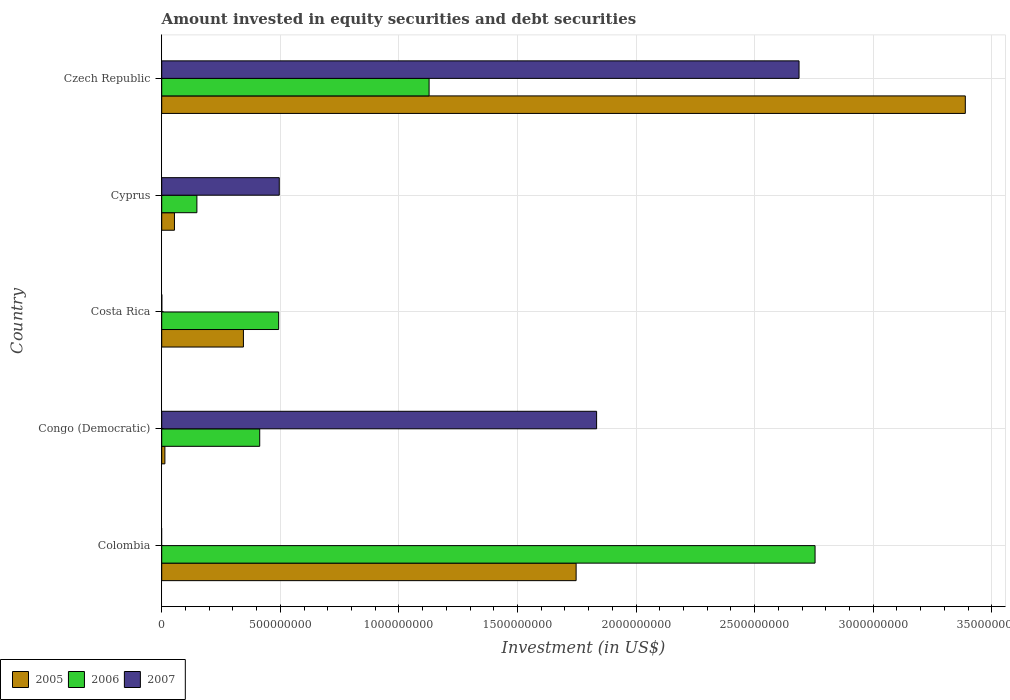Are the number of bars on each tick of the Y-axis equal?
Offer a very short reply. No. What is the label of the 5th group of bars from the top?
Make the answer very short. Colombia. What is the amount invested in equity securities and debt securities in 2006 in Czech Republic?
Offer a terse response. 1.13e+09. Across all countries, what is the maximum amount invested in equity securities and debt securities in 2005?
Your answer should be compact. 3.39e+09. Across all countries, what is the minimum amount invested in equity securities and debt securities in 2005?
Offer a very short reply. 1.34e+07. In which country was the amount invested in equity securities and debt securities in 2007 maximum?
Your response must be concise. Czech Republic. What is the total amount invested in equity securities and debt securities in 2007 in the graph?
Keep it short and to the point. 5.02e+09. What is the difference between the amount invested in equity securities and debt securities in 2007 in Costa Rica and that in Cyprus?
Your answer should be very brief. -4.95e+08. What is the difference between the amount invested in equity securities and debt securities in 2007 in Czech Republic and the amount invested in equity securities and debt securities in 2006 in Colombia?
Your answer should be compact. -6.75e+07. What is the average amount invested in equity securities and debt securities in 2006 per country?
Make the answer very short. 9.87e+08. What is the difference between the amount invested in equity securities and debt securities in 2007 and amount invested in equity securities and debt securities in 2005 in Costa Rica?
Offer a terse response. -3.44e+08. What is the ratio of the amount invested in equity securities and debt securities in 2005 in Colombia to that in Czech Republic?
Provide a short and direct response. 0.52. Is the amount invested in equity securities and debt securities in 2005 in Costa Rica less than that in Cyprus?
Your answer should be very brief. No. Is the difference between the amount invested in equity securities and debt securities in 2007 in Cyprus and Czech Republic greater than the difference between the amount invested in equity securities and debt securities in 2005 in Cyprus and Czech Republic?
Your answer should be compact. Yes. What is the difference between the highest and the second highest amount invested in equity securities and debt securities in 2005?
Offer a very short reply. 1.64e+09. What is the difference between the highest and the lowest amount invested in equity securities and debt securities in 2005?
Your answer should be compact. 3.37e+09. In how many countries, is the amount invested in equity securities and debt securities in 2005 greater than the average amount invested in equity securities and debt securities in 2005 taken over all countries?
Offer a very short reply. 2. Is the sum of the amount invested in equity securities and debt securities in 2007 in Cyprus and Czech Republic greater than the maximum amount invested in equity securities and debt securities in 2006 across all countries?
Provide a short and direct response. Yes. How many bars are there?
Your response must be concise. 14. Are all the bars in the graph horizontal?
Your answer should be compact. Yes. Does the graph contain grids?
Offer a very short reply. Yes. Where does the legend appear in the graph?
Your response must be concise. Bottom left. How many legend labels are there?
Your answer should be very brief. 3. What is the title of the graph?
Make the answer very short. Amount invested in equity securities and debt securities. Does "2014" appear as one of the legend labels in the graph?
Offer a very short reply. No. What is the label or title of the X-axis?
Your response must be concise. Investment (in US$). What is the label or title of the Y-axis?
Offer a very short reply. Country. What is the Investment (in US$) in 2005 in Colombia?
Offer a very short reply. 1.75e+09. What is the Investment (in US$) of 2006 in Colombia?
Ensure brevity in your answer.  2.75e+09. What is the Investment (in US$) in 2007 in Colombia?
Your response must be concise. 0. What is the Investment (in US$) in 2005 in Congo (Democratic)?
Your response must be concise. 1.34e+07. What is the Investment (in US$) of 2006 in Congo (Democratic)?
Make the answer very short. 4.13e+08. What is the Investment (in US$) of 2007 in Congo (Democratic)?
Offer a very short reply. 1.83e+09. What is the Investment (in US$) in 2005 in Costa Rica?
Provide a succinct answer. 3.45e+08. What is the Investment (in US$) in 2006 in Costa Rica?
Your answer should be very brief. 4.93e+08. What is the Investment (in US$) of 2007 in Costa Rica?
Offer a very short reply. 3.93e+05. What is the Investment (in US$) of 2005 in Cyprus?
Offer a terse response. 5.37e+07. What is the Investment (in US$) in 2006 in Cyprus?
Your response must be concise. 1.48e+08. What is the Investment (in US$) in 2007 in Cyprus?
Keep it short and to the point. 4.96e+08. What is the Investment (in US$) of 2005 in Czech Republic?
Provide a short and direct response. 3.39e+09. What is the Investment (in US$) of 2006 in Czech Republic?
Your answer should be compact. 1.13e+09. What is the Investment (in US$) of 2007 in Czech Republic?
Ensure brevity in your answer.  2.69e+09. Across all countries, what is the maximum Investment (in US$) of 2005?
Your response must be concise. 3.39e+09. Across all countries, what is the maximum Investment (in US$) of 2006?
Your answer should be compact. 2.75e+09. Across all countries, what is the maximum Investment (in US$) of 2007?
Make the answer very short. 2.69e+09. Across all countries, what is the minimum Investment (in US$) of 2005?
Offer a terse response. 1.34e+07. Across all countries, what is the minimum Investment (in US$) in 2006?
Offer a terse response. 1.48e+08. Across all countries, what is the minimum Investment (in US$) of 2007?
Your answer should be very brief. 0. What is the total Investment (in US$) in 2005 in the graph?
Your response must be concise. 5.55e+09. What is the total Investment (in US$) of 2006 in the graph?
Make the answer very short. 4.94e+09. What is the total Investment (in US$) of 2007 in the graph?
Provide a succinct answer. 5.02e+09. What is the difference between the Investment (in US$) of 2005 in Colombia and that in Congo (Democratic)?
Offer a terse response. 1.73e+09. What is the difference between the Investment (in US$) in 2006 in Colombia and that in Congo (Democratic)?
Make the answer very short. 2.34e+09. What is the difference between the Investment (in US$) of 2005 in Colombia and that in Costa Rica?
Offer a terse response. 1.40e+09. What is the difference between the Investment (in US$) of 2006 in Colombia and that in Costa Rica?
Your response must be concise. 2.26e+09. What is the difference between the Investment (in US$) in 2005 in Colombia and that in Cyprus?
Offer a terse response. 1.69e+09. What is the difference between the Investment (in US$) of 2006 in Colombia and that in Cyprus?
Offer a very short reply. 2.61e+09. What is the difference between the Investment (in US$) of 2005 in Colombia and that in Czech Republic?
Your answer should be compact. -1.64e+09. What is the difference between the Investment (in US$) in 2006 in Colombia and that in Czech Republic?
Make the answer very short. 1.63e+09. What is the difference between the Investment (in US$) of 2005 in Congo (Democratic) and that in Costa Rica?
Offer a terse response. -3.31e+08. What is the difference between the Investment (in US$) of 2006 in Congo (Democratic) and that in Costa Rica?
Offer a terse response. -7.99e+07. What is the difference between the Investment (in US$) in 2007 in Congo (Democratic) and that in Costa Rica?
Provide a succinct answer. 1.83e+09. What is the difference between the Investment (in US$) in 2005 in Congo (Democratic) and that in Cyprus?
Make the answer very short. -4.03e+07. What is the difference between the Investment (in US$) of 2006 in Congo (Democratic) and that in Cyprus?
Provide a short and direct response. 2.65e+08. What is the difference between the Investment (in US$) of 2007 in Congo (Democratic) and that in Cyprus?
Provide a short and direct response. 1.34e+09. What is the difference between the Investment (in US$) in 2005 in Congo (Democratic) and that in Czech Republic?
Provide a succinct answer. -3.37e+09. What is the difference between the Investment (in US$) of 2006 in Congo (Democratic) and that in Czech Republic?
Make the answer very short. -7.14e+08. What is the difference between the Investment (in US$) of 2007 in Congo (Democratic) and that in Czech Republic?
Provide a succinct answer. -8.54e+08. What is the difference between the Investment (in US$) in 2005 in Costa Rica and that in Cyprus?
Your answer should be compact. 2.91e+08. What is the difference between the Investment (in US$) in 2006 in Costa Rica and that in Cyprus?
Provide a short and direct response. 3.45e+08. What is the difference between the Investment (in US$) of 2007 in Costa Rica and that in Cyprus?
Offer a very short reply. -4.95e+08. What is the difference between the Investment (in US$) of 2005 in Costa Rica and that in Czech Republic?
Offer a very short reply. -3.04e+09. What is the difference between the Investment (in US$) in 2006 in Costa Rica and that in Czech Republic?
Ensure brevity in your answer.  -6.34e+08. What is the difference between the Investment (in US$) in 2007 in Costa Rica and that in Czech Republic?
Offer a terse response. -2.69e+09. What is the difference between the Investment (in US$) of 2005 in Cyprus and that in Czech Republic?
Your response must be concise. -3.33e+09. What is the difference between the Investment (in US$) of 2006 in Cyprus and that in Czech Republic?
Give a very brief answer. -9.79e+08. What is the difference between the Investment (in US$) in 2007 in Cyprus and that in Czech Republic?
Provide a succinct answer. -2.19e+09. What is the difference between the Investment (in US$) in 2005 in Colombia and the Investment (in US$) in 2006 in Congo (Democratic)?
Provide a short and direct response. 1.33e+09. What is the difference between the Investment (in US$) in 2005 in Colombia and the Investment (in US$) in 2007 in Congo (Democratic)?
Your answer should be very brief. -8.64e+07. What is the difference between the Investment (in US$) of 2006 in Colombia and the Investment (in US$) of 2007 in Congo (Democratic)?
Offer a terse response. 9.21e+08. What is the difference between the Investment (in US$) of 2005 in Colombia and the Investment (in US$) of 2006 in Costa Rica?
Your answer should be compact. 1.25e+09. What is the difference between the Investment (in US$) in 2005 in Colombia and the Investment (in US$) in 2007 in Costa Rica?
Make the answer very short. 1.75e+09. What is the difference between the Investment (in US$) of 2006 in Colombia and the Investment (in US$) of 2007 in Costa Rica?
Make the answer very short. 2.75e+09. What is the difference between the Investment (in US$) in 2005 in Colombia and the Investment (in US$) in 2006 in Cyprus?
Your response must be concise. 1.60e+09. What is the difference between the Investment (in US$) in 2005 in Colombia and the Investment (in US$) in 2007 in Cyprus?
Keep it short and to the point. 1.25e+09. What is the difference between the Investment (in US$) in 2006 in Colombia and the Investment (in US$) in 2007 in Cyprus?
Offer a terse response. 2.26e+09. What is the difference between the Investment (in US$) of 2005 in Colombia and the Investment (in US$) of 2006 in Czech Republic?
Offer a terse response. 6.20e+08. What is the difference between the Investment (in US$) of 2005 in Colombia and the Investment (in US$) of 2007 in Czech Republic?
Keep it short and to the point. -9.40e+08. What is the difference between the Investment (in US$) in 2006 in Colombia and the Investment (in US$) in 2007 in Czech Republic?
Your response must be concise. 6.75e+07. What is the difference between the Investment (in US$) of 2005 in Congo (Democratic) and the Investment (in US$) of 2006 in Costa Rica?
Keep it short and to the point. -4.80e+08. What is the difference between the Investment (in US$) of 2005 in Congo (Democratic) and the Investment (in US$) of 2007 in Costa Rica?
Offer a terse response. 1.30e+07. What is the difference between the Investment (in US$) of 2006 in Congo (Democratic) and the Investment (in US$) of 2007 in Costa Rica?
Provide a short and direct response. 4.13e+08. What is the difference between the Investment (in US$) of 2005 in Congo (Democratic) and the Investment (in US$) of 2006 in Cyprus?
Ensure brevity in your answer.  -1.35e+08. What is the difference between the Investment (in US$) in 2005 in Congo (Democratic) and the Investment (in US$) in 2007 in Cyprus?
Keep it short and to the point. -4.82e+08. What is the difference between the Investment (in US$) of 2006 in Congo (Democratic) and the Investment (in US$) of 2007 in Cyprus?
Provide a short and direct response. -8.24e+07. What is the difference between the Investment (in US$) in 2005 in Congo (Democratic) and the Investment (in US$) in 2006 in Czech Republic?
Ensure brevity in your answer.  -1.11e+09. What is the difference between the Investment (in US$) in 2005 in Congo (Democratic) and the Investment (in US$) in 2007 in Czech Republic?
Keep it short and to the point. -2.67e+09. What is the difference between the Investment (in US$) in 2006 in Congo (Democratic) and the Investment (in US$) in 2007 in Czech Republic?
Keep it short and to the point. -2.27e+09. What is the difference between the Investment (in US$) of 2005 in Costa Rica and the Investment (in US$) of 2006 in Cyprus?
Provide a succinct answer. 1.96e+08. What is the difference between the Investment (in US$) in 2005 in Costa Rica and the Investment (in US$) in 2007 in Cyprus?
Offer a very short reply. -1.51e+08. What is the difference between the Investment (in US$) of 2006 in Costa Rica and the Investment (in US$) of 2007 in Cyprus?
Give a very brief answer. -2.46e+06. What is the difference between the Investment (in US$) of 2005 in Costa Rica and the Investment (in US$) of 2006 in Czech Republic?
Make the answer very short. -7.83e+08. What is the difference between the Investment (in US$) in 2005 in Costa Rica and the Investment (in US$) in 2007 in Czech Republic?
Your answer should be very brief. -2.34e+09. What is the difference between the Investment (in US$) in 2006 in Costa Rica and the Investment (in US$) in 2007 in Czech Republic?
Provide a succinct answer. -2.19e+09. What is the difference between the Investment (in US$) in 2005 in Cyprus and the Investment (in US$) in 2006 in Czech Republic?
Make the answer very short. -1.07e+09. What is the difference between the Investment (in US$) of 2005 in Cyprus and the Investment (in US$) of 2007 in Czech Republic?
Your answer should be very brief. -2.63e+09. What is the difference between the Investment (in US$) in 2006 in Cyprus and the Investment (in US$) in 2007 in Czech Republic?
Keep it short and to the point. -2.54e+09. What is the average Investment (in US$) in 2005 per country?
Offer a terse response. 1.11e+09. What is the average Investment (in US$) of 2006 per country?
Your response must be concise. 9.87e+08. What is the average Investment (in US$) of 2007 per country?
Provide a succinct answer. 1.00e+09. What is the difference between the Investment (in US$) of 2005 and Investment (in US$) of 2006 in Colombia?
Provide a short and direct response. -1.01e+09. What is the difference between the Investment (in US$) in 2005 and Investment (in US$) in 2006 in Congo (Democratic)?
Your response must be concise. -4.00e+08. What is the difference between the Investment (in US$) of 2005 and Investment (in US$) of 2007 in Congo (Democratic)?
Ensure brevity in your answer.  -1.82e+09. What is the difference between the Investment (in US$) of 2006 and Investment (in US$) of 2007 in Congo (Democratic)?
Provide a succinct answer. -1.42e+09. What is the difference between the Investment (in US$) of 2005 and Investment (in US$) of 2006 in Costa Rica?
Keep it short and to the point. -1.49e+08. What is the difference between the Investment (in US$) of 2005 and Investment (in US$) of 2007 in Costa Rica?
Your answer should be compact. 3.44e+08. What is the difference between the Investment (in US$) in 2006 and Investment (in US$) in 2007 in Costa Rica?
Your response must be concise. 4.93e+08. What is the difference between the Investment (in US$) in 2005 and Investment (in US$) in 2006 in Cyprus?
Give a very brief answer. -9.46e+07. What is the difference between the Investment (in US$) in 2005 and Investment (in US$) in 2007 in Cyprus?
Your response must be concise. -4.42e+08. What is the difference between the Investment (in US$) of 2006 and Investment (in US$) of 2007 in Cyprus?
Ensure brevity in your answer.  -3.47e+08. What is the difference between the Investment (in US$) in 2005 and Investment (in US$) in 2006 in Czech Republic?
Make the answer very short. 2.26e+09. What is the difference between the Investment (in US$) in 2005 and Investment (in US$) in 2007 in Czech Republic?
Give a very brief answer. 7.01e+08. What is the difference between the Investment (in US$) of 2006 and Investment (in US$) of 2007 in Czech Republic?
Offer a terse response. -1.56e+09. What is the ratio of the Investment (in US$) in 2005 in Colombia to that in Congo (Democratic)?
Your answer should be compact. 130.39. What is the ratio of the Investment (in US$) of 2005 in Colombia to that in Costa Rica?
Your answer should be very brief. 5.07. What is the ratio of the Investment (in US$) in 2006 in Colombia to that in Costa Rica?
Offer a terse response. 5.59. What is the ratio of the Investment (in US$) in 2005 in Colombia to that in Cyprus?
Make the answer very short. 32.51. What is the ratio of the Investment (in US$) of 2006 in Colombia to that in Cyprus?
Your answer should be very brief. 18.57. What is the ratio of the Investment (in US$) of 2005 in Colombia to that in Czech Republic?
Provide a succinct answer. 0.52. What is the ratio of the Investment (in US$) of 2006 in Colombia to that in Czech Republic?
Your response must be concise. 2.44. What is the ratio of the Investment (in US$) of 2005 in Congo (Democratic) to that in Costa Rica?
Provide a short and direct response. 0.04. What is the ratio of the Investment (in US$) in 2006 in Congo (Democratic) to that in Costa Rica?
Provide a short and direct response. 0.84. What is the ratio of the Investment (in US$) of 2007 in Congo (Democratic) to that in Costa Rica?
Your answer should be very brief. 4671.29. What is the ratio of the Investment (in US$) in 2005 in Congo (Democratic) to that in Cyprus?
Make the answer very short. 0.25. What is the ratio of the Investment (in US$) in 2006 in Congo (Democratic) to that in Cyprus?
Your answer should be very brief. 2.79. What is the ratio of the Investment (in US$) in 2007 in Congo (Democratic) to that in Cyprus?
Give a very brief answer. 3.7. What is the ratio of the Investment (in US$) in 2005 in Congo (Democratic) to that in Czech Republic?
Your response must be concise. 0. What is the ratio of the Investment (in US$) of 2006 in Congo (Democratic) to that in Czech Republic?
Give a very brief answer. 0.37. What is the ratio of the Investment (in US$) in 2007 in Congo (Democratic) to that in Czech Republic?
Your response must be concise. 0.68. What is the ratio of the Investment (in US$) of 2005 in Costa Rica to that in Cyprus?
Provide a succinct answer. 6.41. What is the ratio of the Investment (in US$) in 2006 in Costa Rica to that in Cyprus?
Give a very brief answer. 3.32. What is the ratio of the Investment (in US$) of 2007 in Costa Rica to that in Cyprus?
Your answer should be very brief. 0. What is the ratio of the Investment (in US$) in 2005 in Costa Rica to that in Czech Republic?
Make the answer very short. 0.1. What is the ratio of the Investment (in US$) in 2006 in Costa Rica to that in Czech Republic?
Make the answer very short. 0.44. What is the ratio of the Investment (in US$) in 2007 in Costa Rica to that in Czech Republic?
Offer a very short reply. 0. What is the ratio of the Investment (in US$) of 2005 in Cyprus to that in Czech Republic?
Offer a terse response. 0.02. What is the ratio of the Investment (in US$) of 2006 in Cyprus to that in Czech Republic?
Keep it short and to the point. 0.13. What is the ratio of the Investment (in US$) of 2007 in Cyprus to that in Czech Republic?
Keep it short and to the point. 0.18. What is the difference between the highest and the second highest Investment (in US$) of 2005?
Make the answer very short. 1.64e+09. What is the difference between the highest and the second highest Investment (in US$) in 2006?
Offer a terse response. 1.63e+09. What is the difference between the highest and the second highest Investment (in US$) in 2007?
Your answer should be compact. 8.54e+08. What is the difference between the highest and the lowest Investment (in US$) of 2005?
Offer a terse response. 3.37e+09. What is the difference between the highest and the lowest Investment (in US$) in 2006?
Keep it short and to the point. 2.61e+09. What is the difference between the highest and the lowest Investment (in US$) in 2007?
Offer a terse response. 2.69e+09. 